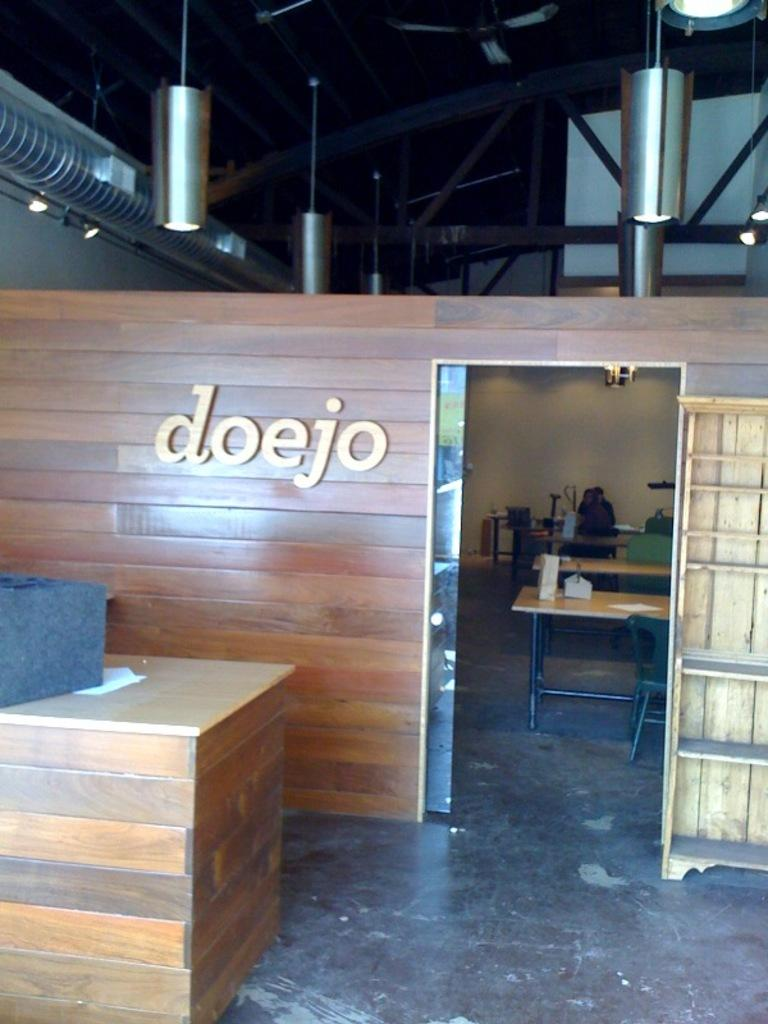<image>
Create a compact narrative representing the image presented. A counter is in front of a room that is labeled doejo. 